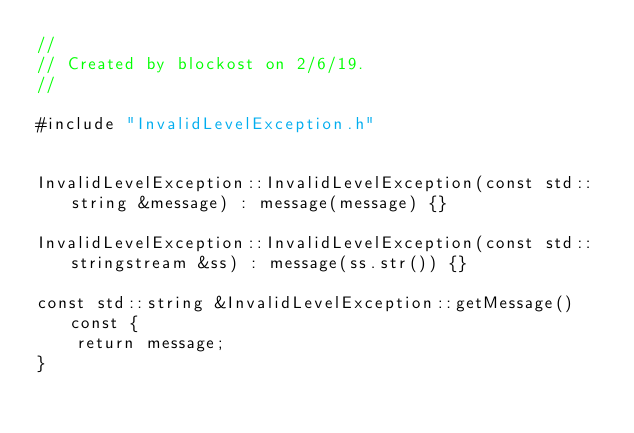Convert code to text. <code><loc_0><loc_0><loc_500><loc_500><_C++_>//
// Created by blockost on 2/6/19.
//

#include "InvalidLevelException.h"


InvalidLevelException::InvalidLevelException(const std::string &message) : message(message) {}

InvalidLevelException::InvalidLevelException(const std::stringstream &ss) : message(ss.str()) {}

const std::string &InvalidLevelException::getMessage() const {
    return message;
}
</code> 